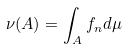Convert formula to latex. <formula><loc_0><loc_0><loc_500><loc_500>\nu ( A ) = \int _ { A } f _ { n } d \mu</formula> 